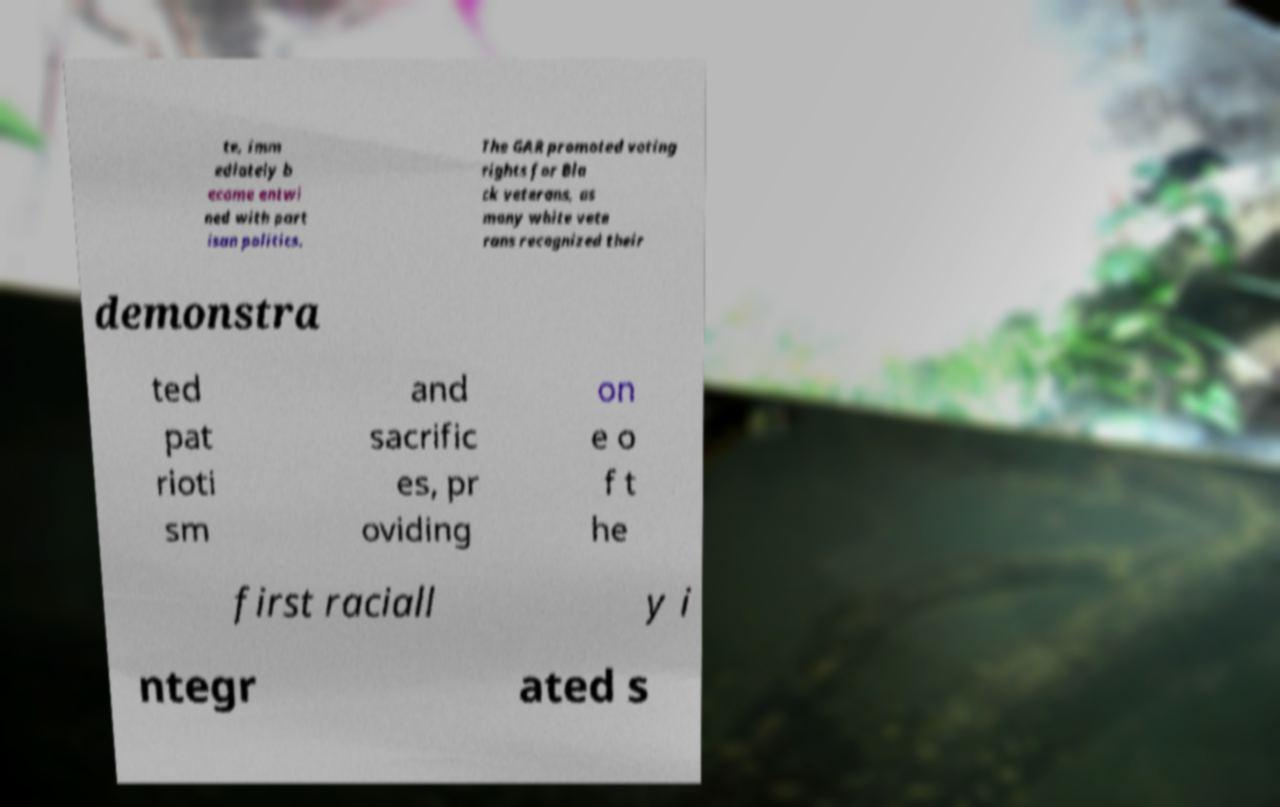For documentation purposes, I need the text within this image transcribed. Could you provide that? te, imm ediately b ecame entwi ned with part isan politics. The GAR promoted voting rights for Bla ck veterans, as many white vete rans recognized their demonstra ted pat rioti sm and sacrific es, pr oviding on e o f t he first raciall y i ntegr ated s 